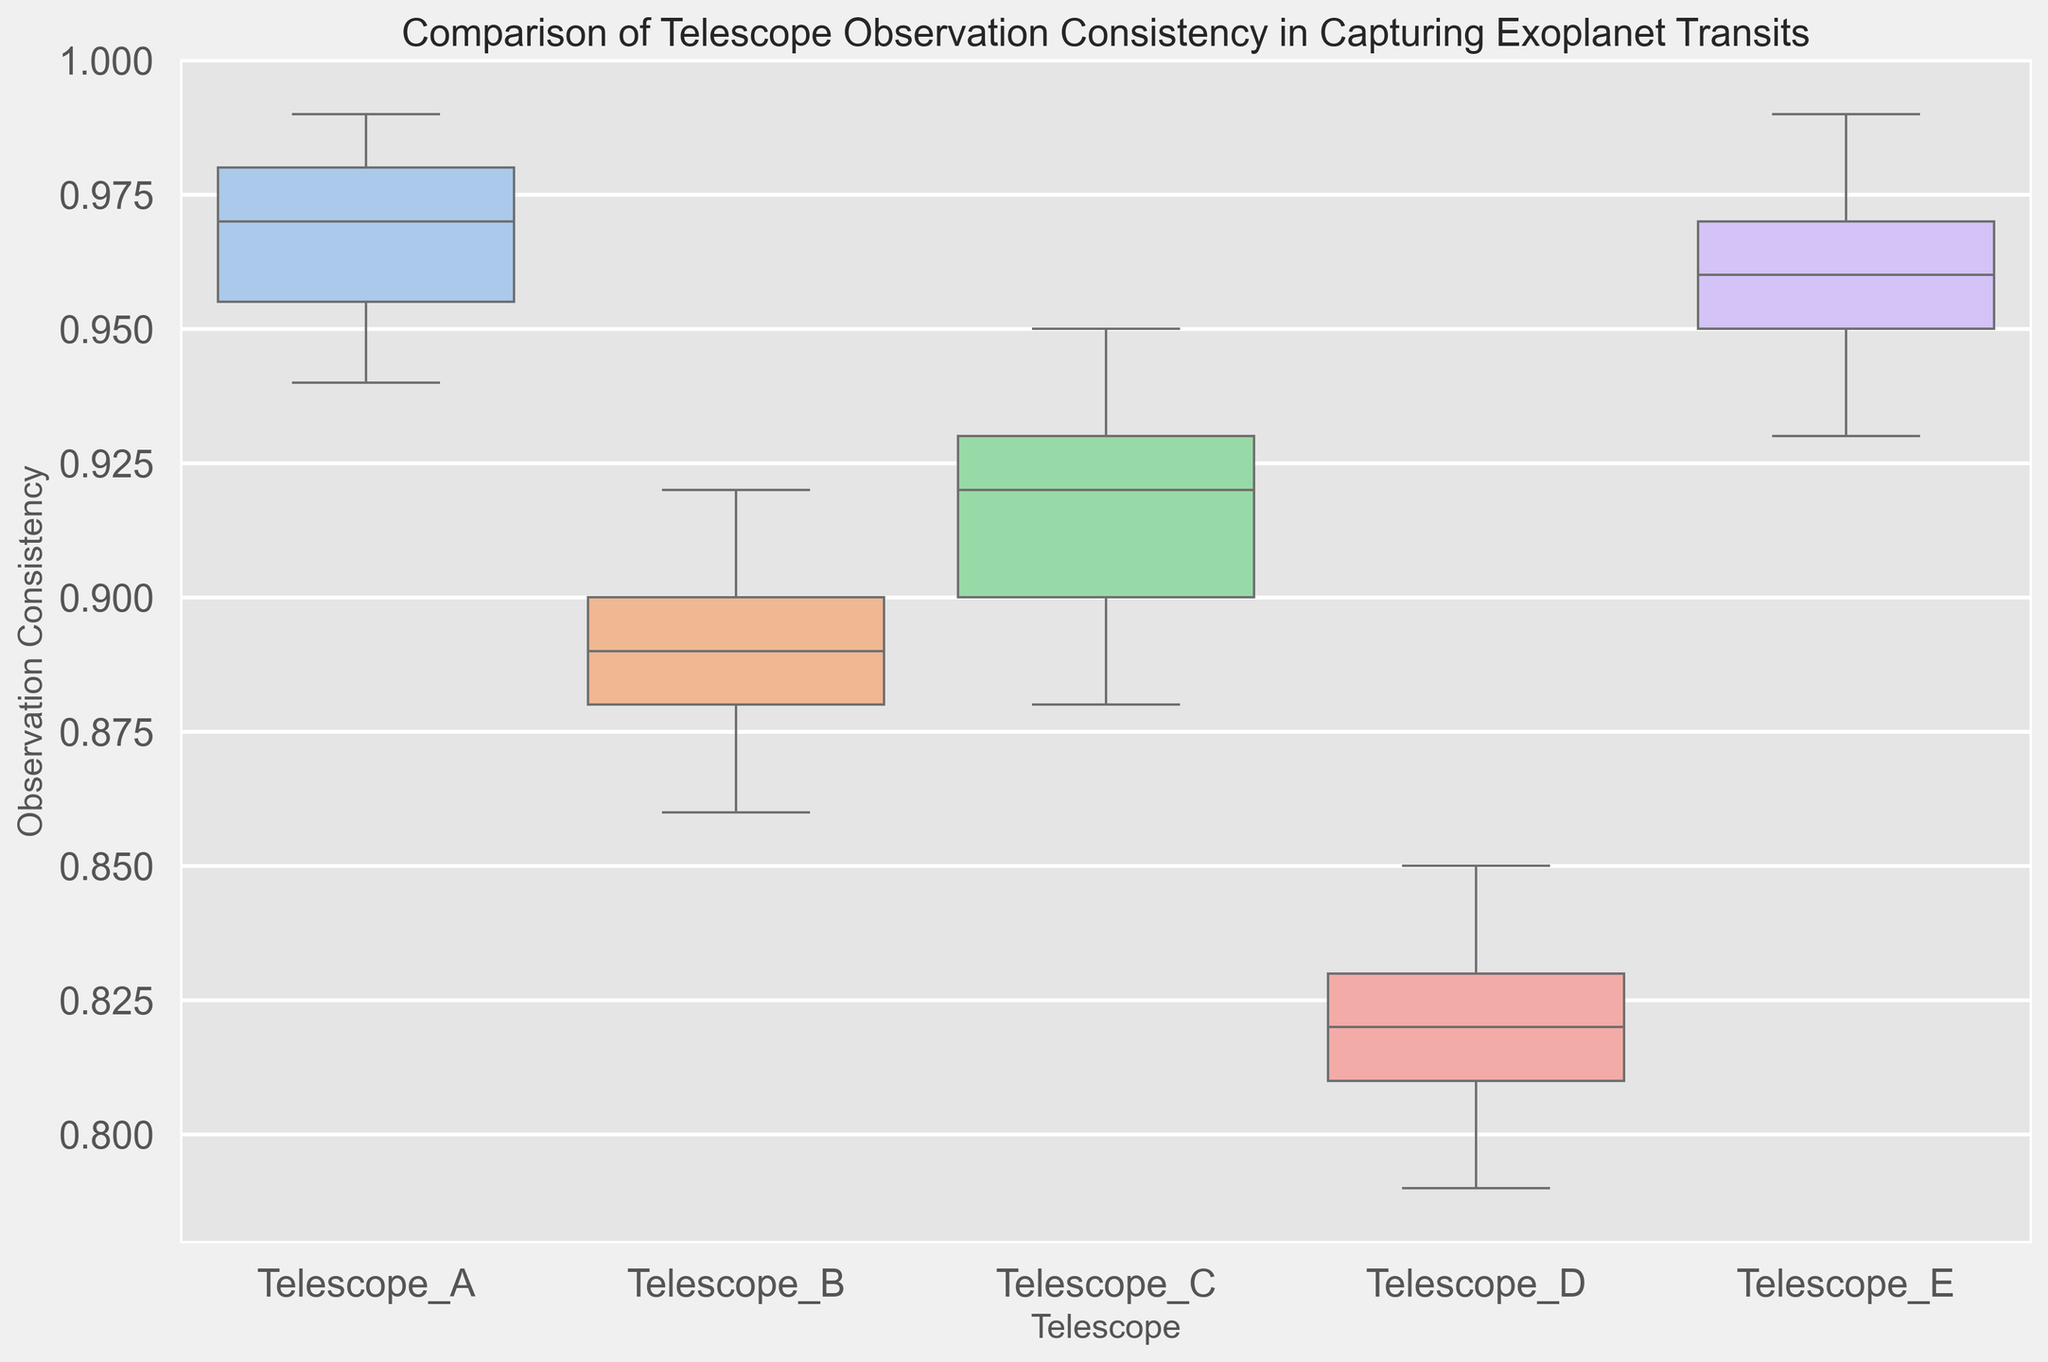Which telescope shows the highest median observation consistency? To find the highest median observation consistency, we need to identify the middle value of each box plot and compare them. The median is represented by the line inside each box.
Answer: Telescope_A Which telescope has the widest range of observation consistency? The range is determined by the distance between the top and bottom whiskers in each box plot. Comparing these, we can see which telescope has the largest difference between its highest and lowest values.
Answer: Telescope_C Among Telescopes A, B, and C, which has the lowest minimum observation consistency? The minimum value for each telescope is represented by the bottom whisker of the respective box plot. Compare the positions of the lowest whisker points for Telescopes A, B, and C.
Answer: Telescope_B Which telescope's observations have the smallest interquartile range (IQR)? The IQR is the range between the first quartile (bottom of the box) and the third quartile (top of the box). By examining the boxes' heights, we determine which is the smallest.
Answer: Telescope_E How do the upper whisker lengths of Telescopes D and E compare? To compare, look at the length of the whiskers above the boxes for both Telescopes D and E.
Answer: Telescope_E has a shorter upper whisker compared to Telescope_D Which two telescopes have the most similar observation consistency distributions? For this, we compare the box plots' overall shape, including medians, ranges, and IQRs, looking for the two most similar appearances.
Answer: Telescopes_A and E How does the median observation consistency of Telescope_B compare to that of Telescope_D? Locate the median (line inside the box) for both Telescopes B and D, and compare their values.
Answer: Telescope_B has a higher median than Telescope_D What is the main difference between the observation consistency distributions of Telescopes A and C? Compare the shapes, heights, and positions of the boxes and whiskers for Telescopes A and C to identify the main distinction.
Answer: Telescope_A has higher overall consistency and a more compact range compared to Telescope_C What is the highest observation consistency achieved by any telescope, and which telescope achieves this? Look for the highest point on all box plots, which is the top end of the whisker or outlier.
Answer: 0.99 by Telescopes_A and E Between Telescopes C and D, which one has a greater spread in the lower 50% of their data? Examine the distance between the minimum value and the median value (line inside the box) for Telescopes C and D to determine the one with a greater lower spread.
Answer: Telescope_C 